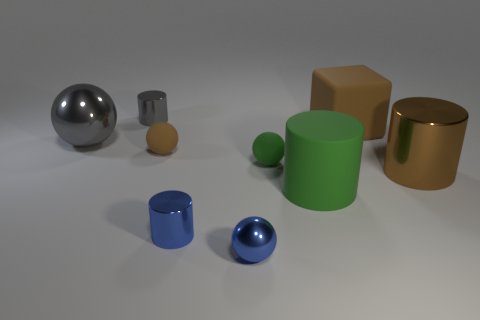Subtract all blue cubes. Subtract all gray balls. How many cubes are left? 1 Add 1 green balls. How many objects exist? 10 Subtract all balls. How many objects are left? 5 Subtract all brown things. Subtract all small things. How many objects are left? 1 Add 4 big shiny spheres. How many big shiny spheres are left? 5 Add 3 tiny rubber spheres. How many tiny rubber spheres exist? 5 Subtract 0 red spheres. How many objects are left? 9 